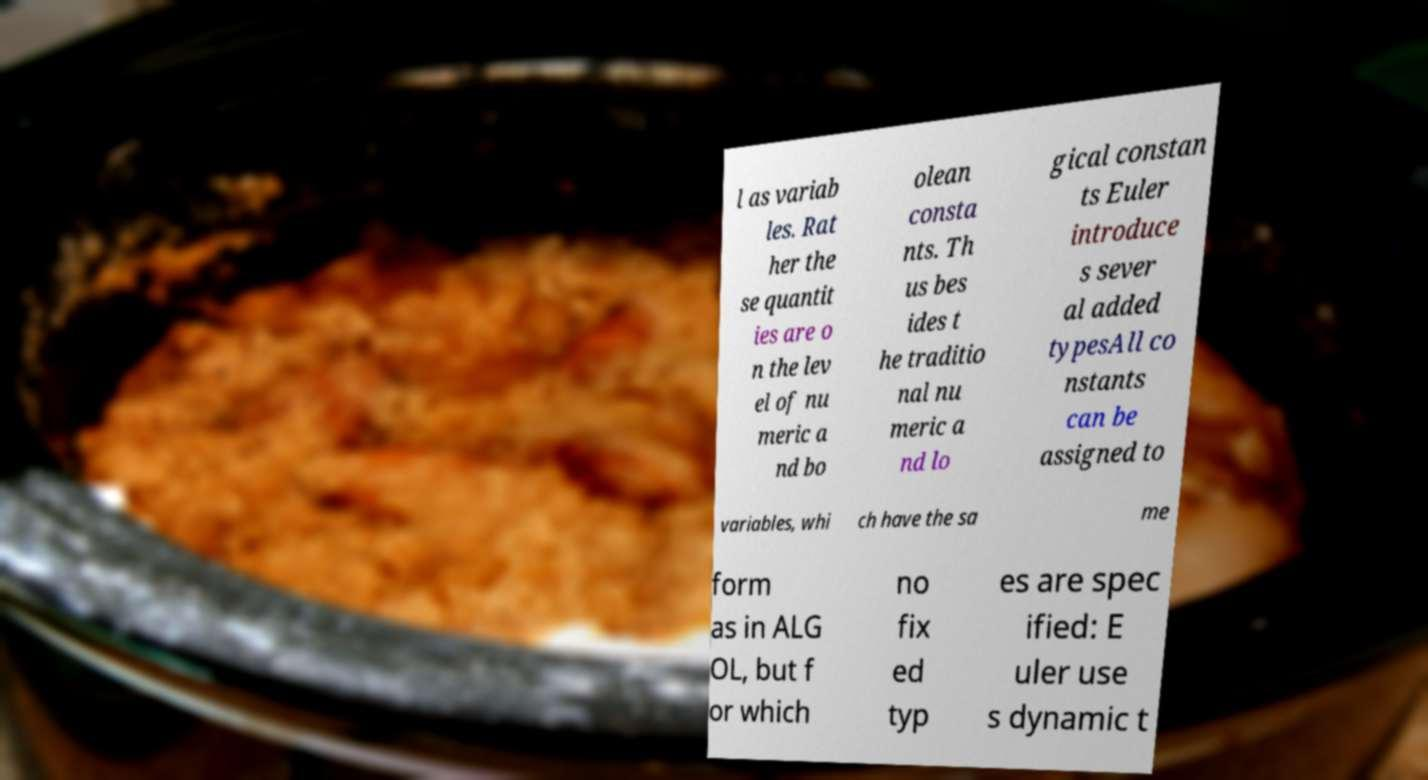Could you extract and type out the text from this image? l as variab les. Rat her the se quantit ies are o n the lev el of nu meric a nd bo olean consta nts. Th us bes ides t he traditio nal nu meric a nd lo gical constan ts Euler introduce s sever al added typesAll co nstants can be assigned to variables, whi ch have the sa me form as in ALG OL, but f or which no fix ed typ es are spec ified: E uler use s dynamic t 